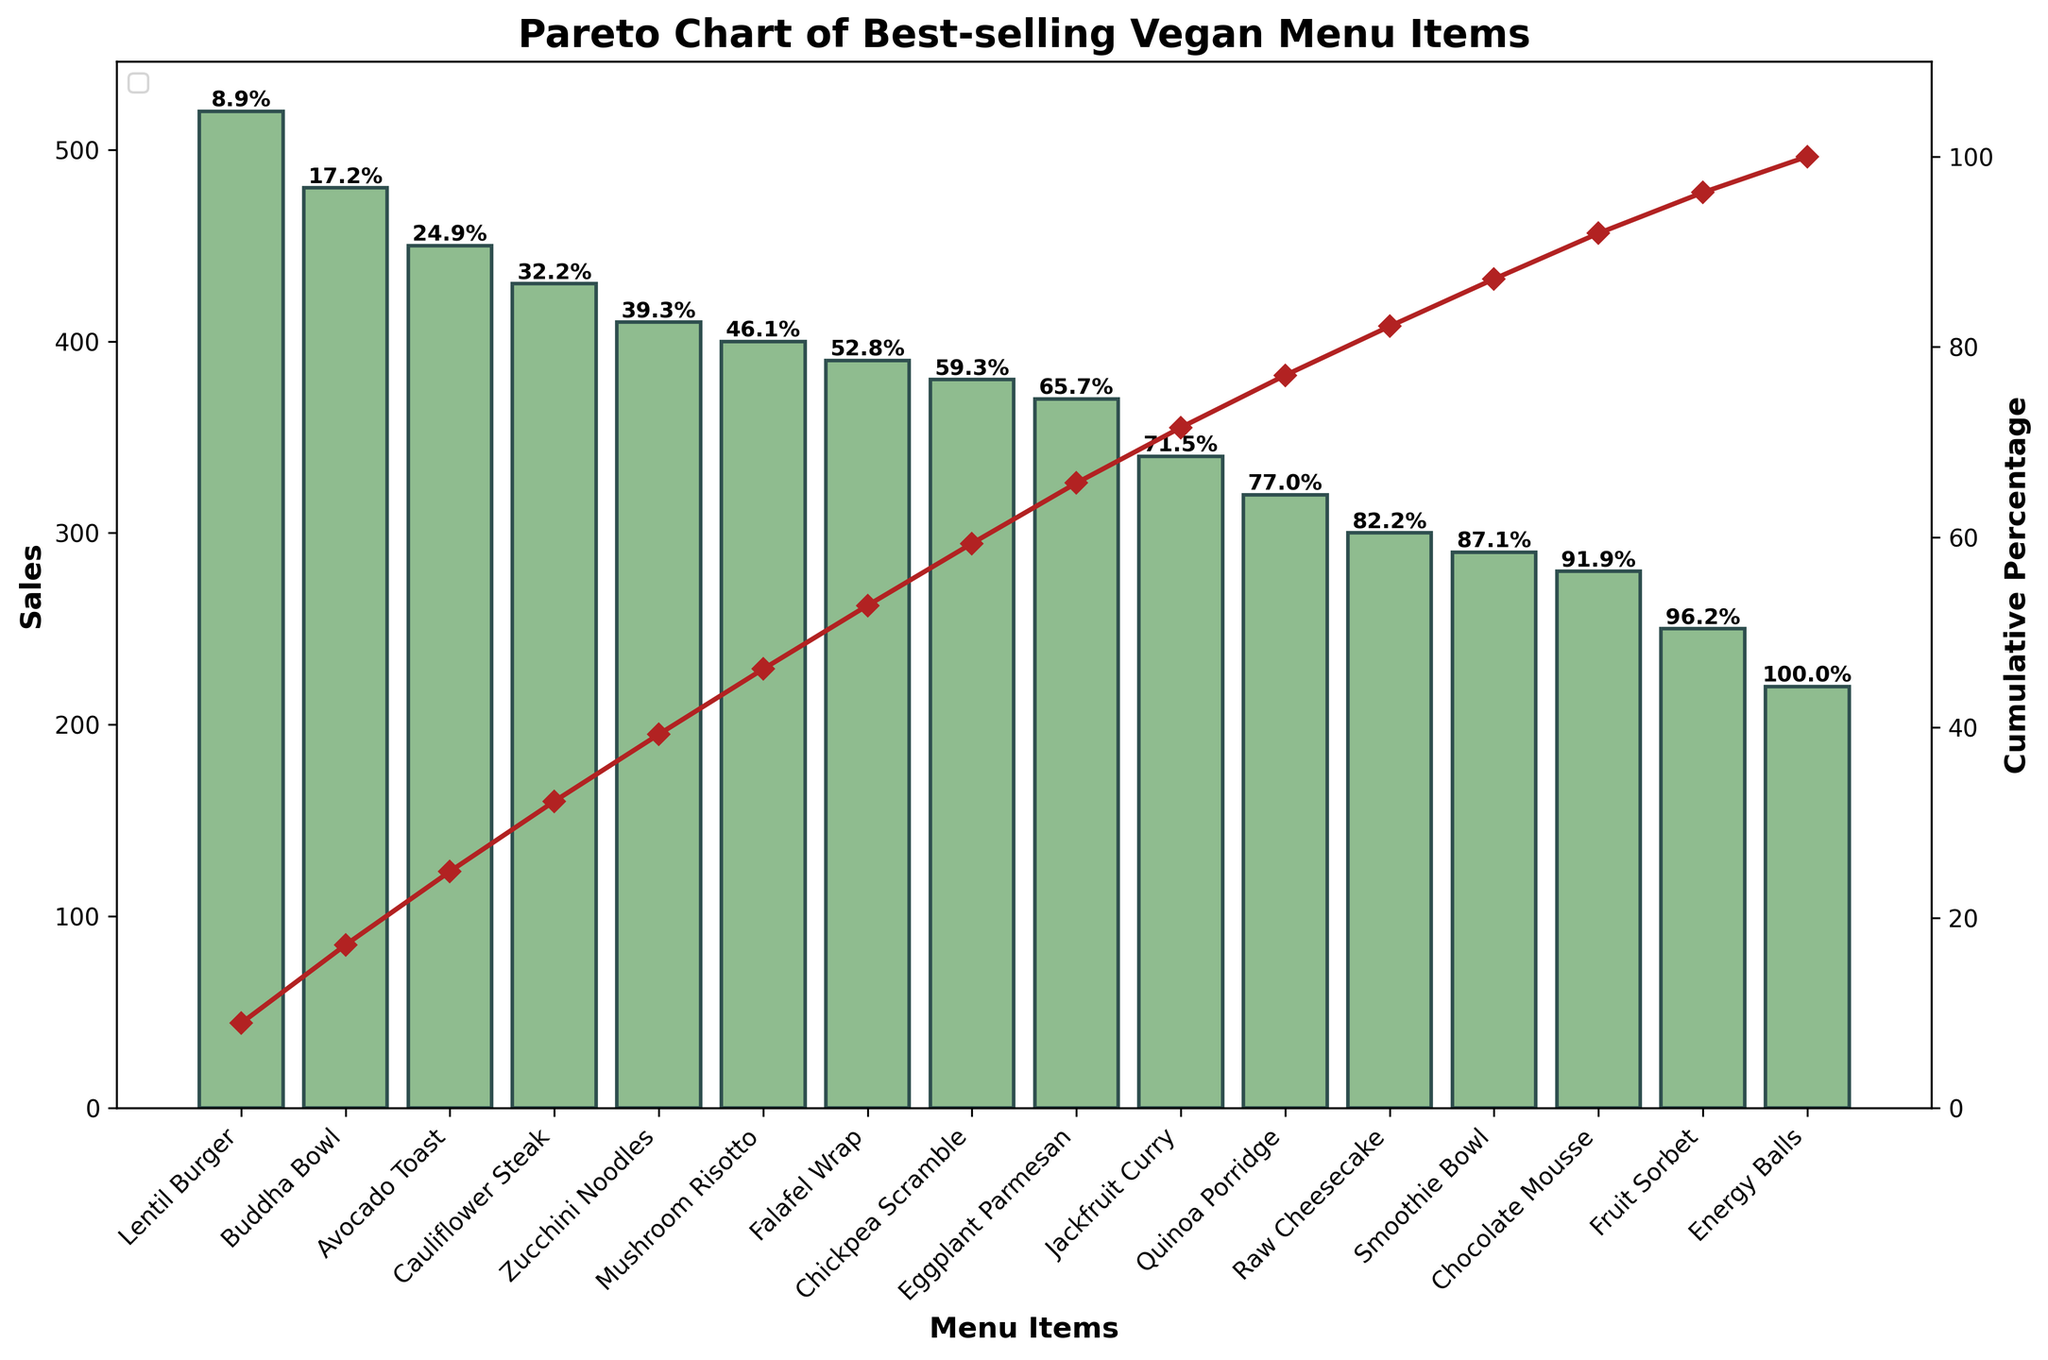What is the title of the chart? The title of the chart is usually displayed at the top and describes the main topic of the figure. Here, it reads 'Pareto Chart of Best-selling Vegan Menu Items'.
Answer: Pareto Chart of Best-selling Vegan Menu Items Which breakfast item has the highest sales? By looking at the breakfast items (Avocado Toast, Chickpea Scramble, Quinoa Porridge, Smoothie Bowl), we can see that Avocado Toast has the highest bars among them.
Answer: Avocado Toast What is the cumulative percentage of sales for the Lentil Burger? Locate the Lentil Burger bar and read the percentage text above it for the cumulative percentage. It's the first bar, and it shows the value clearly as a label.
Answer: Approximately 13% Which meal type category has the item with the highest sales? Identify the bar with the maximum sales value and find its corresponding meal type. The Lentil Burger has the highest sales, which comes from the Lunch category.
Answer: Lunch How much higher is the sales of Cauliflower Steak compared to Jackfruit Curry? Locate the bars for Cauliflower Steak (430 sales) and Jackfruit Curry (340 sales). Subtract Jackfruit Curry's sales from Cauliflower Steak's sales (430 - 340).
Answer: 90 What item marks the 50% cumulative sales threshold? Track the cumulative percentage line until it reaches 50%. The corresponding bar below it is the item 'Zucchini Noodles'.
Answer: Zucchini Noodles What is the cumulative percentage after the first three highest-selling items? Identify the cumulative percentage after the Lentil Burger, Buddha Bowl, and Avocado Toast. Look at the value labeled above the third bar (Avocado Toast).
Answer: Approximately 35% Which dessert item has the lowest sales? Among dessert items (Raw Cheesecake, Chocolate Mousse, Fruit Sorbet, Energy Balls), compare their bar heights. Energy Balls has the lowest bar.
Answer: Energy Balls By what percentage do the top four items contribute to the total sales? Sum up the cumulative percentages of the top four items: Lentil Burger, Buddha Bowl, Avocado Toast, and Cauliflower Steak.
Answer: Approximately 44% How does the cumulative percentage change between Zucchini Noodles and Falafel Wrap? Identify the cumulative percentage at Zucchini Noodles and compare it with the percentage at Falafel Wrap. The difference between their percentages gives the change.
Answer: Approximately 8% 